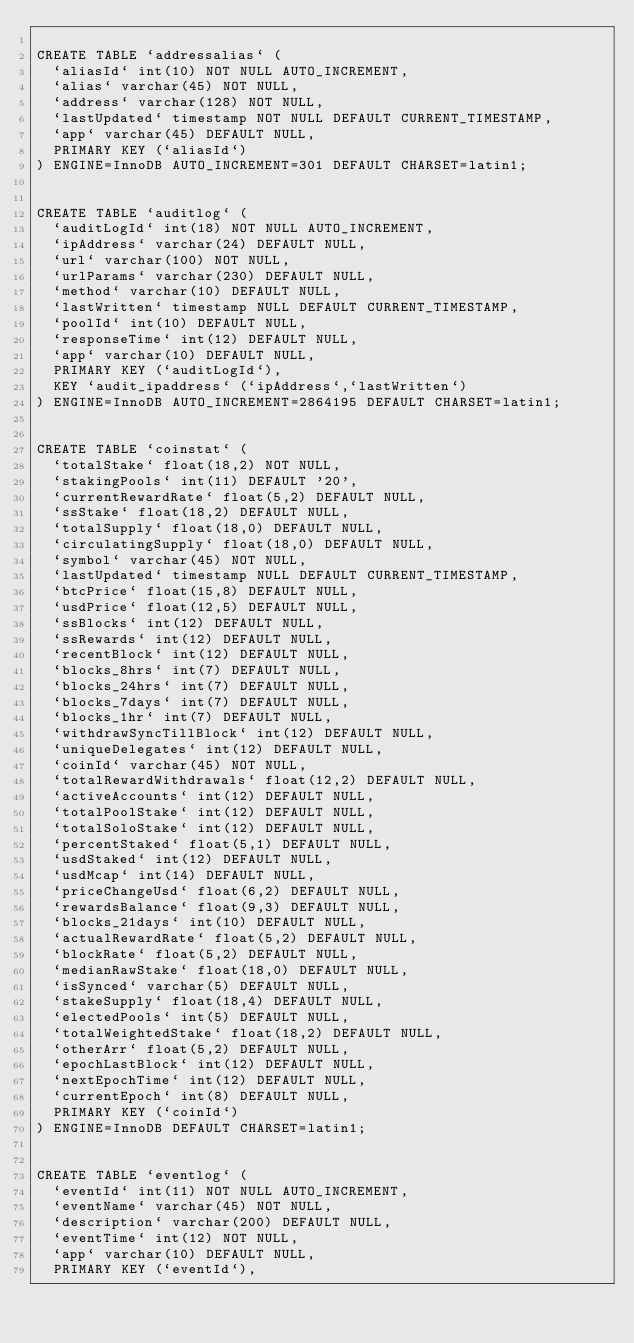Convert code to text. <code><loc_0><loc_0><loc_500><loc_500><_SQL_>
CREATE TABLE `addressalias` (
  `aliasId` int(10) NOT NULL AUTO_INCREMENT,
  `alias` varchar(45) NOT NULL,
  `address` varchar(128) NOT NULL,
  `lastUpdated` timestamp NOT NULL DEFAULT CURRENT_TIMESTAMP,
  `app` varchar(45) DEFAULT NULL,
  PRIMARY KEY (`aliasId`)
) ENGINE=InnoDB AUTO_INCREMENT=301 DEFAULT CHARSET=latin1;


CREATE TABLE `auditlog` (
  `auditLogId` int(18) NOT NULL AUTO_INCREMENT,
  `ipAddress` varchar(24) DEFAULT NULL,
  `url` varchar(100) NOT NULL,
  `urlParams` varchar(230) DEFAULT NULL,
  `method` varchar(10) DEFAULT NULL,
  `lastWritten` timestamp NULL DEFAULT CURRENT_TIMESTAMP,
  `poolId` int(10) DEFAULT NULL,
  `responseTime` int(12) DEFAULT NULL,
  `app` varchar(10) DEFAULT NULL,
  PRIMARY KEY (`auditLogId`),
  KEY `audit_ipaddress` (`ipAddress`,`lastWritten`)
) ENGINE=InnoDB AUTO_INCREMENT=2864195 DEFAULT CHARSET=latin1;


CREATE TABLE `coinstat` (
  `totalStake` float(18,2) NOT NULL,
  `stakingPools` int(11) DEFAULT '20',
  `currentRewardRate` float(5,2) DEFAULT NULL,
  `ssStake` float(18,2) DEFAULT NULL,
  `totalSupply` float(18,0) DEFAULT NULL,
  `circulatingSupply` float(18,0) DEFAULT NULL,
  `symbol` varchar(45) NOT NULL,
  `lastUpdated` timestamp NULL DEFAULT CURRENT_TIMESTAMP,
  `btcPrice` float(15,8) DEFAULT NULL,
  `usdPrice` float(12,5) DEFAULT NULL,
  `ssBlocks` int(12) DEFAULT NULL,
  `ssRewards` int(12) DEFAULT NULL,
  `recentBlock` int(12) DEFAULT NULL,
  `blocks_8hrs` int(7) DEFAULT NULL,
  `blocks_24hrs` int(7) DEFAULT NULL,
  `blocks_7days` int(7) DEFAULT NULL,
  `blocks_1hr` int(7) DEFAULT NULL,
  `withdrawSyncTillBlock` int(12) DEFAULT NULL,
  `uniqueDelegates` int(12) DEFAULT NULL,
  `coinId` varchar(45) NOT NULL,
  `totalRewardWithdrawals` float(12,2) DEFAULT NULL,
  `activeAccounts` int(12) DEFAULT NULL,
  `totalPoolStake` int(12) DEFAULT NULL,
  `totalSoloStake` int(12) DEFAULT NULL,
  `percentStaked` float(5,1) DEFAULT NULL,
  `usdStaked` int(12) DEFAULT NULL,
  `usdMcap` int(14) DEFAULT NULL,
  `priceChangeUsd` float(6,2) DEFAULT NULL,
  `rewardsBalance` float(9,3) DEFAULT NULL,
  `blocks_21days` int(10) DEFAULT NULL,
  `actualRewardRate` float(5,2) DEFAULT NULL,
  `blockRate` float(5,2) DEFAULT NULL,
  `medianRawStake` float(18,0) DEFAULT NULL,
  `isSynced` varchar(5) DEFAULT NULL,
  `stakeSupply` float(18,4) DEFAULT NULL,
  `electedPools` int(5) DEFAULT NULL,
  `totalWeightedStake` float(18,2) DEFAULT NULL,
  `otherArr` float(5,2) DEFAULT NULL,
  `epochLastBlock` int(12) DEFAULT NULL,
  `nextEpochTime` int(12) DEFAULT NULL,
  `currentEpoch` int(8) DEFAULT NULL,
  PRIMARY KEY (`coinId`)
) ENGINE=InnoDB DEFAULT CHARSET=latin1;


CREATE TABLE `eventlog` (
  `eventId` int(11) NOT NULL AUTO_INCREMENT,
  `eventName` varchar(45) NOT NULL,
  `description` varchar(200) DEFAULT NULL,
  `eventTime` int(12) NOT NULL,
  `app` varchar(10) DEFAULT NULL,
  PRIMARY KEY (`eventId`),</code> 